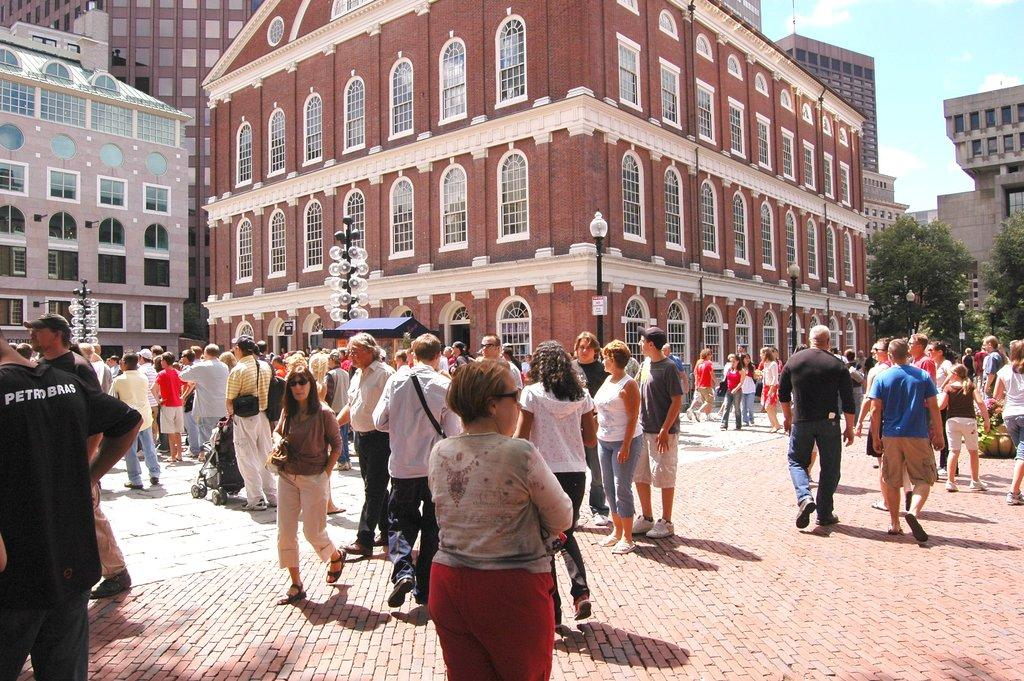<image>
Render a clear and concise summary of the photo. A man in a Petrobas shirt walks in a crowd with other tourists. 